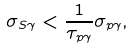Convert formula to latex. <formula><loc_0><loc_0><loc_500><loc_500>\sigma _ { S \gamma } < \frac { 1 } { \tau _ { p \gamma } } \sigma _ { p \gamma } ,</formula> 